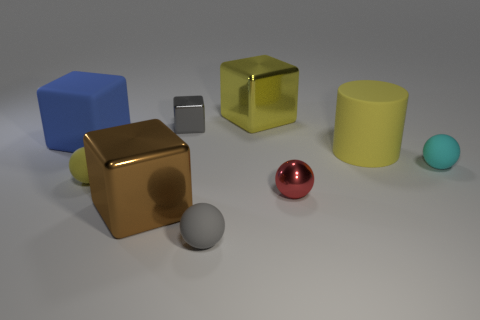Subtract all rubber balls. How many balls are left? 1 Subtract all cyan cubes. Subtract all gray balls. How many cubes are left? 4 Add 1 big green metallic blocks. How many objects exist? 10 Subtract all cylinders. How many objects are left? 8 Subtract 0 gray cylinders. How many objects are left? 9 Subtract all small things. Subtract all tiny cyan spheres. How many objects are left? 3 Add 2 small metal things. How many small metal things are left? 4 Add 4 red metal cylinders. How many red metal cylinders exist? 4 